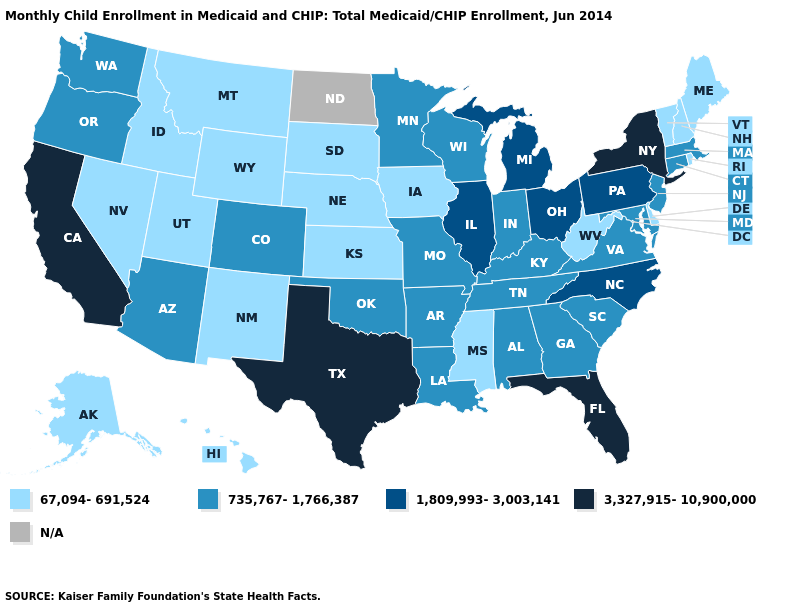Among the states that border New Mexico , does Utah have the lowest value?
Keep it brief. Yes. What is the value of Florida?
Be succinct. 3,327,915-10,900,000. What is the value of Nebraska?
Answer briefly. 67,094-691,524. How many symbols are there in the legend?
Concise answer only. 5. Which states have the lowest value in the USA?
Concise answer only. Alaska, Delaware, Hawaii, Idaho, Iowa, Kansas, Maine, Mississippi, Montana, Nebraska, Nevada, New Hampshire, New Mexico, Rhode Island, South Dakota, Utah, Vermont, West Virginia, Wyoming. What is the highest value in states that border Minnesota?
Answer briefly. 735,767-1,766,387. Name the states that have a value in the range 735,767-1,766,387?
Quick response, please. Alabama, Arizona, Arkansas, Colorado, Connecticut, Georgia, Indiana, Kentucky, Louisiana, Maryland, Massachusetts, Minnesota, Missouri, New Jersey, Oklahoma, Oregon, South Carolina, Tennessee, Virginia, Washington, Wisconsin. Does the first symbol in the legend represent the smallest category?
Give a very brief answer. Yes. Which states have the lowest value in the USA?
Be succinct. Alaska, Delaware, Hawaii, Idaho, Iowa, Kansas, Maine, Mississippi, Montana, Nebraska, Nevada, New Hampshire, New Mexico, Rhode Island, South Dakota, Utah, Vermont, West Virginia, Wyoming. Does North Carolina have the highest value in the USA?
Quick response, please. No. How many symbols are there in the legend?
Concise answer only. 5. Among the states that border Maryland , which have the lowest value?
Quick response, please. Delaware, West Virginia. Name the states that have a value in the range 1,809,993-3,003,141?
Quick response, please. Illinois, Michigan, North Carolina, Ohio, Pennsylvania. Which states have the lowest value in the USA?
Be succinct. Alaska, Delaware, Hawaii, Idaho, Iowa, Kansas, Maine, Mississippi, Montana, Nebraska, Nevada, New Hampshire, New Mexico, Rhode Island, South Dakota, Utah, Vermont, West Virginia, Wyoming. 